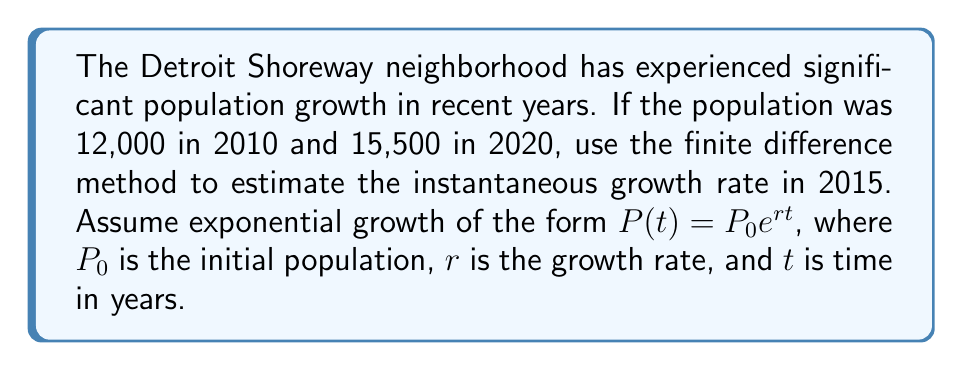Could you help me with this problem? To solve this problem, we'll use the finite difference method to approximate the instantaneous growth rate in 2015. Here's the step-by-step process:

1) We have two data points:
   $P(0) = 12,000$ (2010)
   $P(10) = 15,500$ (2020)

2) The exponential growth model is $P(t) = P_0e^{rt}$

3) We can find the average growth rate over the 10-year period:
   $$\frac{P(10)}{P(0)} = e^{10r}$$
   $$\frac{15,500}{12,000} = e^{10r}$$

4) Taking the natural log of both sides:
   $$\ln(\frac{15,500}{12,000}) = 10r$$

5) Solving for $r$:
   $$r = \frac{1}{10}\ln(\frac{15,500}{12,000}) \approx 0.0256$$

6) This gives us the average growth rate over the 10-year period. To estimate the instantaneous growth rate in 2015 (t = 5), we can use the central difference formula:

   $$r(5) \approx \frac{P(10) - P(0)}{10P(5)}$$

7) We need to estimate $P(5)$. Using the average growth rate:
   $$P(5) = 12,000 * e^{0.0256 * 5} \approx 13,659$$

8) Now we can calculate the instantaneous growth rate:
   $$r(5) \approx \frac{15,500 - 12,000}{10 * 13,659} \approx 0.0256$$

This coincidentally matches our average growth rate due to the exponential nature of the growth.
Answer: 0.0256 or 2.56% 